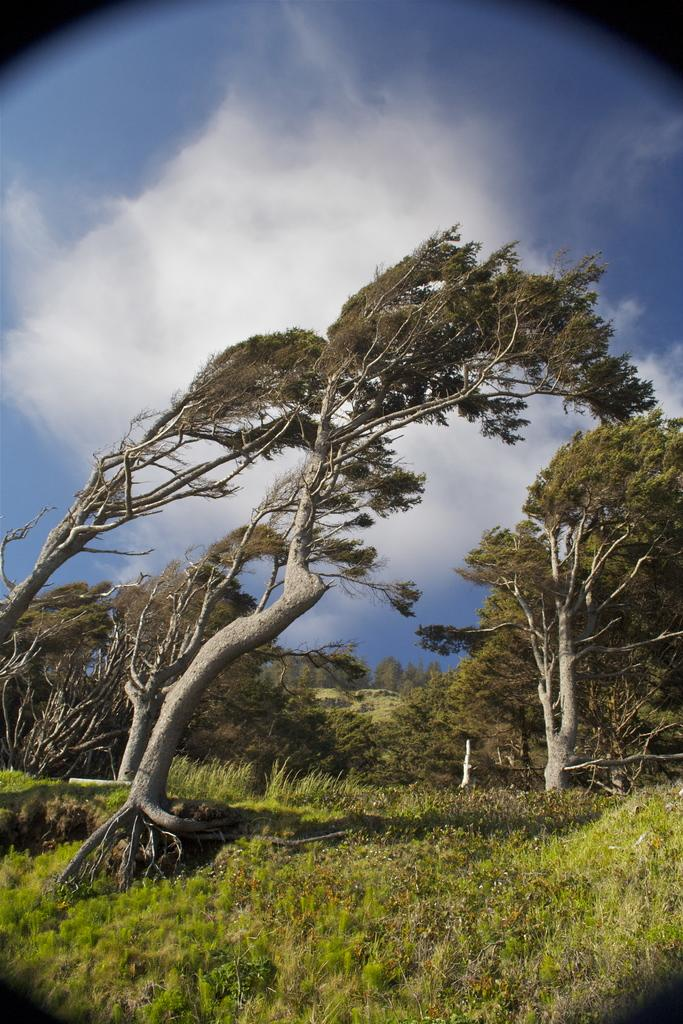What type of vegetation can be seen in the image? There are trees, grass, and plants in the image. What is visible in the background of the image? The sky is visible in the image. What can be seen in the sky? There are clouds in the sky. What type of toothbrush is the beggar using in the image? There is no toothbrush or beggar present in the image. What is the title of the image? The image does not have a title, as it is not a piece of artwork or literature. 